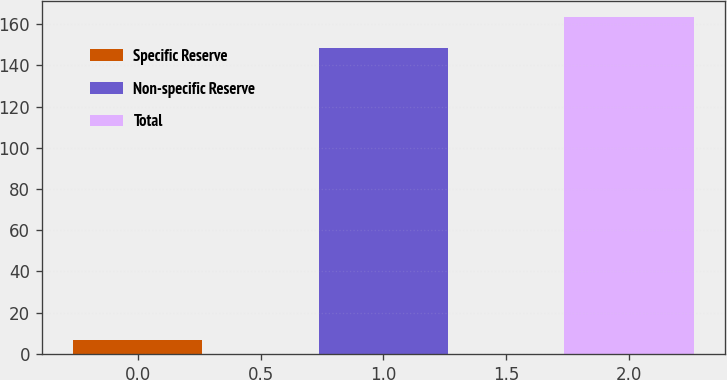Convert chart to OTSL. <chart><loc_0><loc_0><loc_500><loc_500><bar_chart><fcel>Specific Reserve<fcel>Non-specific Reserve<fcel>Total<nl><fcel>6.6<fcel>148.4<fcel>163.24<nl></chart> 